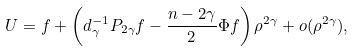<formula> <loc_0><loc_0><loc_500><loc_500>U = f + \left ( d _ { \gamma } ^ { - 1 } P _ { 2 \gamma } f - \frac { n - 2 \gamma } { 2 } \Phi f \right ) \rho ^ { 2 \gamma } + o ( \rho ^ { 2 \gamma } ) ,</formula> 